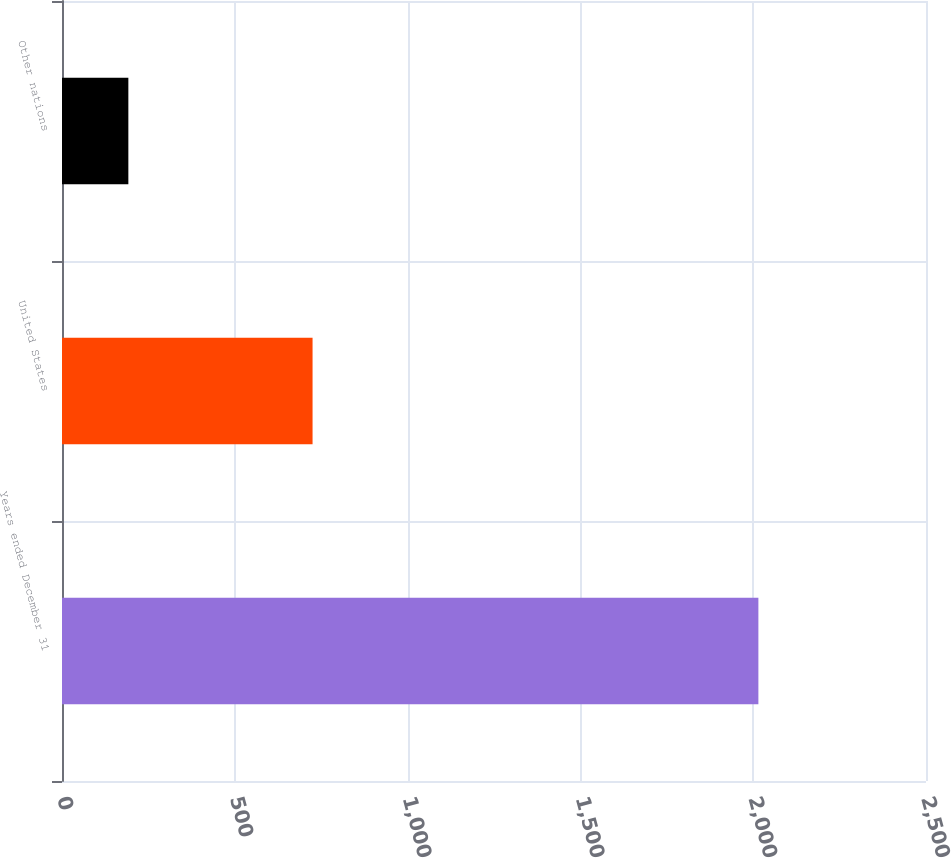Convert chart to OTSL. <chart><loc_0><loc_0><loc_500><loc_500><bar_chart><fcel>Years ended December 31<fcel>United States<fcel>Other nations<nl><fcel>2015<fcel>725<fcel>192<nl></chart> 